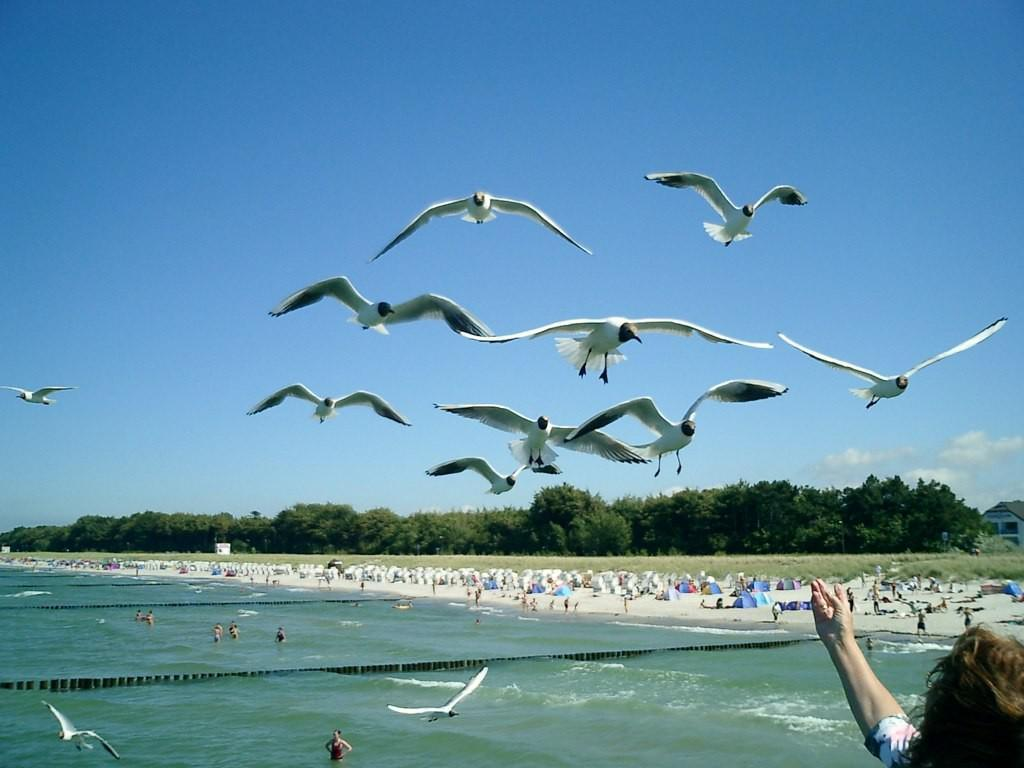What type of vehicles can be seen in the image? There are boats in the image. What type of natural environment is visible in the image? There are trees and water visible in the image. What part of the natural environment is not visible in the image? The ground is not visible in the image. What is visible in the sky in the image? The sky is visible in the image. Where is the trail located in the image? There is no trail present in the image. Who is the representative of the boats in the image? There is no representative present in the image; the boats are the main subject. 